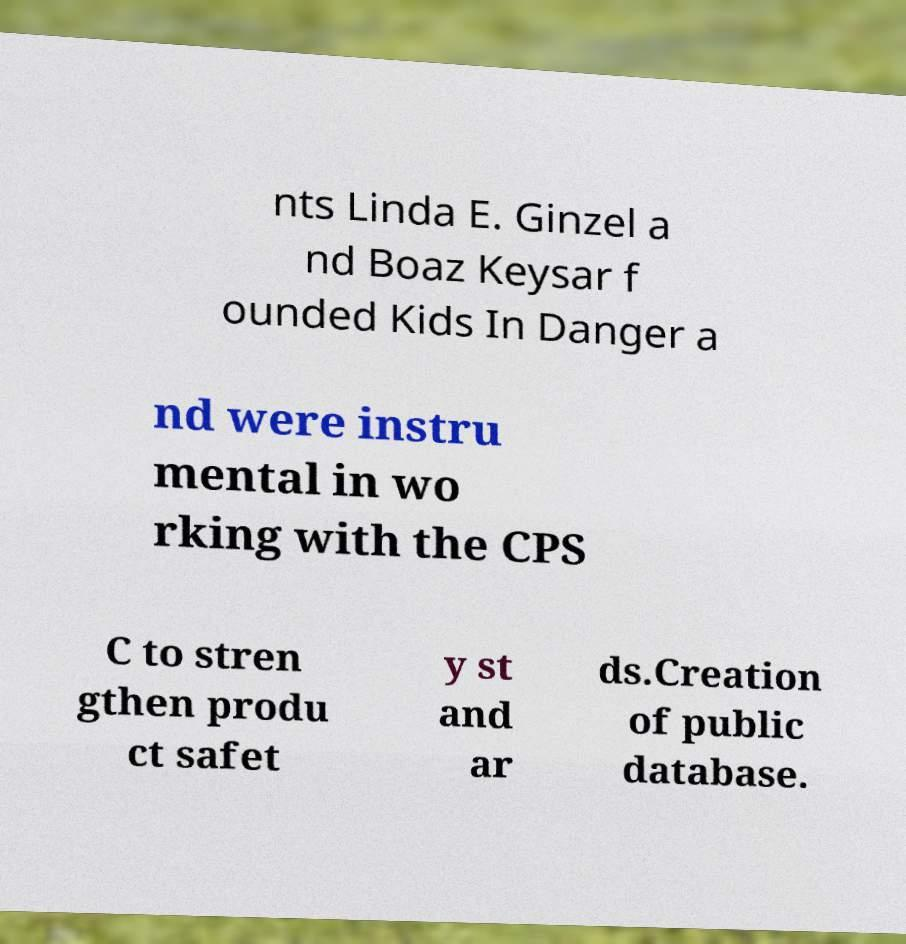I need the written content from this picture converted into text. Can you do that? nts Linda E. Ginzel a nd Boaz Keysar f ounded Kids In Danger a nd were instru mental in wo rking with the CPS C to stren gthen produ ct safet y st and ar ds.Creation of public database. 